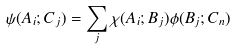Convert formula to latex. <formula><loc_0><loc_0><loc_500><loc_500>\psi ( A _ { i } ; C _ { j } ) = \sum _ { j } \chi ( A _ { i } ; B _ { j } ) \phi ( B _ { j } ; C _ { n } )</formula> 